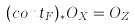Convert formula to latex. <formula><loc_0><loc_0><loc_500><loc_500>( c o n t _ { F } ) _ { * } O _ { X } = O _ { Z }</formula> 